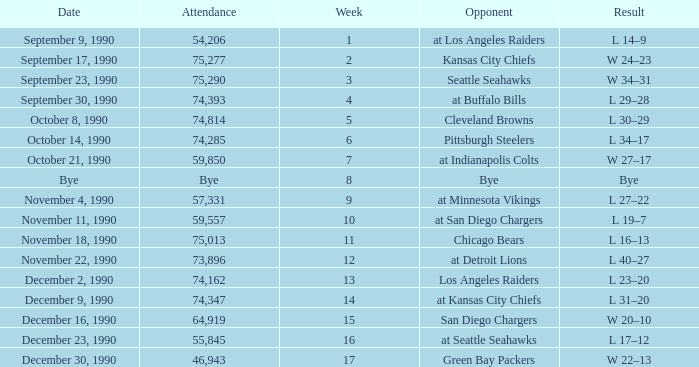How many weeks was there an attendance of 74,347? 14.0. 